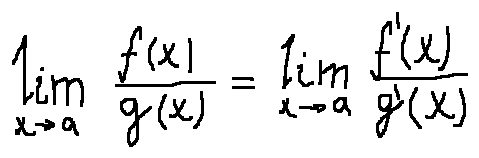<formula> <loc_0><loc_0><loc_500><loc_500>\lim \lim i t s _ { x \rightarrow a } \frac { f ( x ) } { g ( x ) } = \lim \lim i t s _ { x \rightarrow a } \frac { f ^ { \prime } ( x ) } { g ^ { \prime } ( x ) }</formula> 